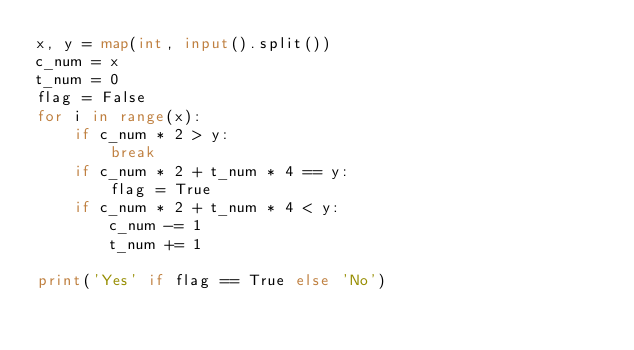<code> <loc_0><loc_0><loc_500><loc_500><_Python_>x, y = map(int, input().split())
c_num = x
t_num = 0
flag = False
for i in range(x):
    if c_num * 2 > y:
        break
    if c_num * 2 + t_num * 4 == y:
        flag = True
    if c_num * 2 + t_num * 4 < y:
        c_num -= 1
        t_num += 1

print('Yes' if flag == True else 'No')</code> 